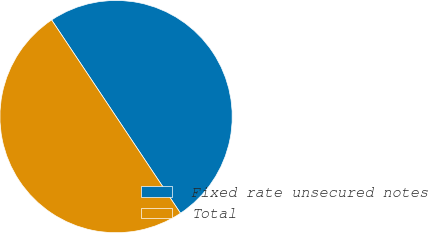Convert chart to OTSL. <chart><loc_0><loc_0><loc_500><loc_500><pie_chart><fcel>Fixed rate unsecured notes<fcel>Total<nl><fcel>50.0%<fcel>50.0%<nl></chart> 